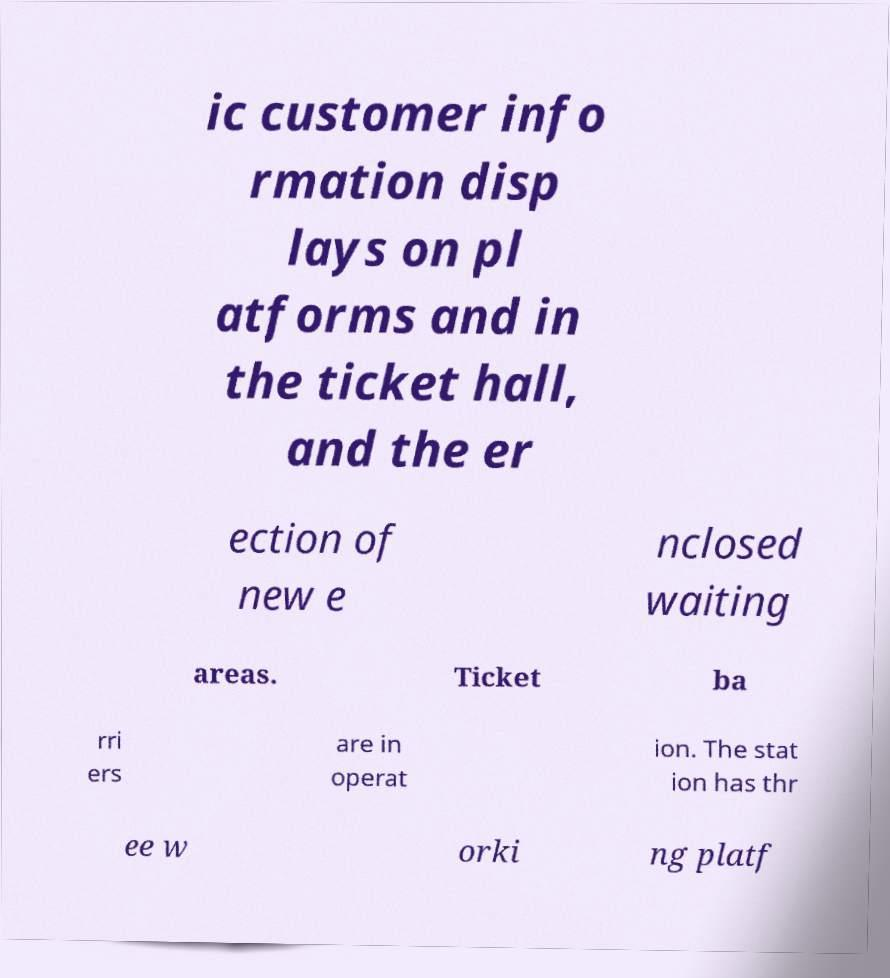Could you extract and type out the text from this image? ic customer info rmation disp lays on pl atforms and in the ticket hall, and the er ection of new e nclosed waiting areas. Ticket ba rri ers are in operat ion. The stat ion has thr ee w orki ng platf 